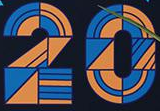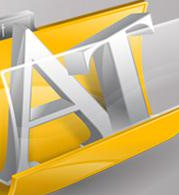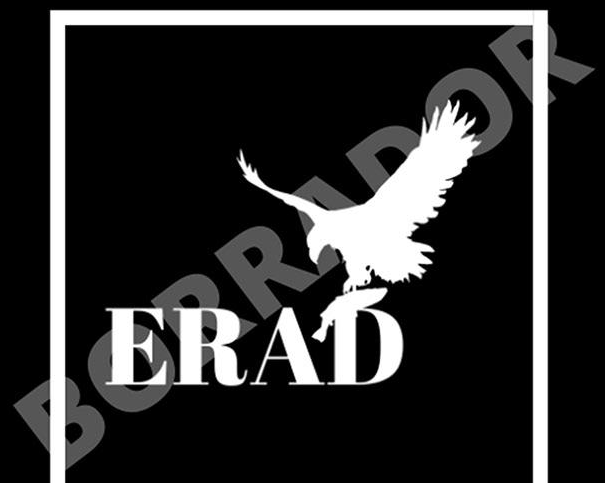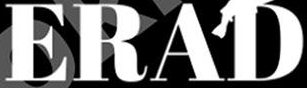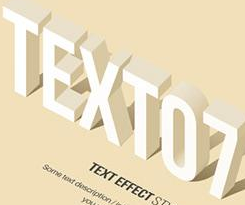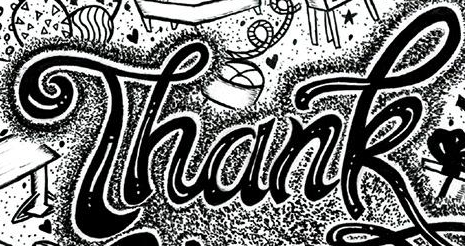What words are shown in these images in order, separated by a semicolon? 20; AT; BORRADOR; ERAD; TEXTO7; Thank 